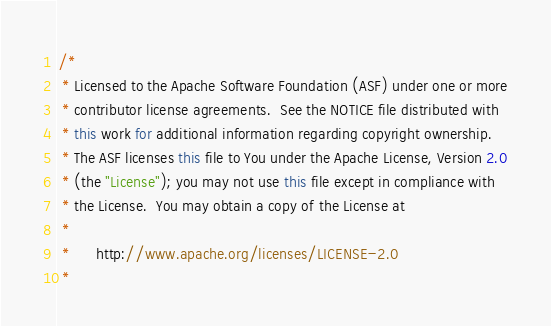Convert code to text. <code><loc_0><loc_0><loc_500><loc_500><_Java_>/*
 * Licensed to the Apache Software Foundation (ASF) under one or more
 * contributor license agreements.  See the NOTICE file distributed with
 * this work for additional information regarding copyright ownership.
 * The ASF licenses this file to You under the Apache License, Version 2.0
 * (the "License"); you may not use this file except in compliance with
 * the License.  You may obtain a copy of the License at
 *
 *      http://www.apache.org/licenses/LICENSE-2.0
 *</code> 